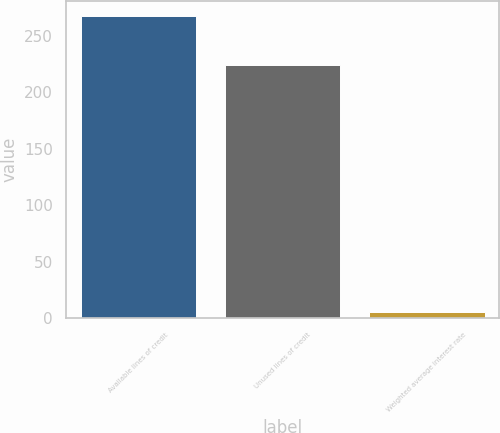<chart> <loc_0><loc_0><loc_500><loc_500><bar_chart><fcel>Available lines of credit<fcel>Unused lines of credit<fcel>Weighted average interest rate<nl><fcel>267.3<fcel>224.4<fcel>5.5<nl></chart> 